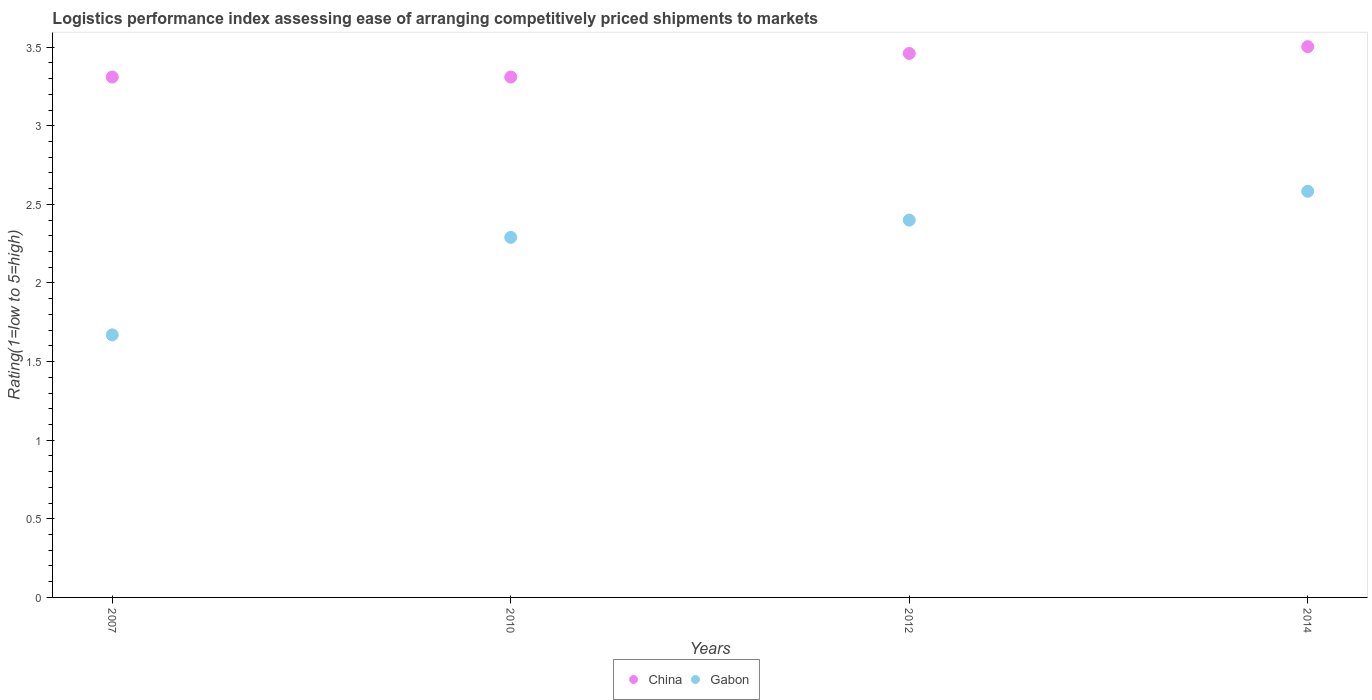Is the number of dotlines equal to the number of legend labels?
Give a very brief answer. Yes. What is the Logistic performance index in China in 2010?
Give a very brief answer. 3.31. Across all years, what is the maximum Logistic performance index in China?
Your answer should be compact. 3.5. Across all years, what is the minimum Logistic performance index in Gabon?
Your answer should be compact. 1.67. In which year was the Logistic performance index in China maximum?
Make the answer very short. 2014. What is the total Logistic performance index in China in the graph?
Keep it short and to the point. 13.58. What is the difference between the Logistic performance index in China in 2007 and that in 2014?
Offer a terse response. -0.19. What is the difference between the Logistic performance index in China in 2014 and the Logistic performance index in Gabon in 2007?
Your answer should be compact. 1.83. What is the average Logistic performance index in China per year?
Offer a very short reply. 3.4. In the year 2010, what is the difference between the Logistic performance index in Gabon and Logistic performance index in China?
Offer a very short reply. -1.02. In how many years, is the Logistic performance index in Gabon greater than 0.2?
Provide a succinct answer. 4. What is the ratio of the Logistic performance index in China in 2007 to that in 2010?
Keep it short and to the point. 1. Is the Logistic performance index in Gabon in 2007 less than that in 2014?
Your response must be concise. Yes. Is the difference between the Logistic performance index in Gabon in 2007 and 2014 greater than the difference between the Logistic performance index in China in 2007 and 2014?
Make the answer very short. No. What is the difference between the highest and the second highest Logistic performance index in Gabon?
Your response must be concise. 0.18. What is the difference between the highest and the lowest Logistic performance index in Gabon?
Ensure brevity in your answer.  0.91. Does the Logistic performance index in China monotonically increase over the years?
Your answer should be compact. No. Is the Logistic performance index in Gabon strictly greater than the Logistic performance index in China over the years?
Give a very brief answer. No. Is the Logistic performance index in Gabon strictly less than the Logistic performance index in China over the years?
Ensure brevity in your answer.  Yes. How many years are there in the graph?
Offer a terse response. 4. Are the values on the major ticks of Y-axis written in scientific E-notation?
Offer a terse response. No. How many legend labels are there?
Offer a terse response. 2. How are the legend labels stacked?
Give a very brief answer. Horizontal. What is the title of the graph?
Make the answer very short. Logistics performance index assessing ease of arranging competitively priced shipments to markets. What is the label or title of the X-axis?
Your response must be concise. Years. What is the label or title of the Y-axis?
Provide a short and direct response. Rating(1=low to 5=high). What is the Rating(1=low to 5=high) of China in 2007?
Give a very brief answer. 3.31. What is the Rating(1=low to 5=high) in Gabon in 2007?
Your answer should be compact. 1.67. What is the Rating(1=low to 5=high) in China in 2010?
Your answer should be very brief. 3.31. What is the Rating(1=low to 5=high) in Gabon in 2010?
Make the answer very short. 2.29. What is the Rating(1=low to 5=high) of China in 2012?
Keep it short and to the point. 3.46. What is the Rating(1=low to 5=high) of Gabon in 2012?
Keep it short and to the point. 2.4. What is the Rating(1=low to 5=high) of China in 2014?
Offer a terse response. 3.5. What is the Rating(1=low to 5=high) in Gabon in 2014?
Offer a terse response. 2.58. Across all years, what is the maximum Rating(1=low to 5=high) of China?
Your response must be concise. 3.5. Across all years, what is the maximum Rating(1=low to 5=high) in Gabon?
Make the answer very short. 2.58. Across all years, what is the minimum Rating(1=low to 5=high) of China?
Provide a succinct answer. 3.31. Across all years, what is the minimum Rating(1=low to 5=high) in Gabon?
Provide a short and direct response. 1.67. What is the total Rating(1=low to 5=high) in China in the graph?
Your answer should be very brief. 13.58. What is the total Rating(1=low to 5=high) of Gabon in the graph?
Make the answer very short. 8.94. What is the difference between the Rating(1=low to 5=high) of Gabon in 2007 and that in 2010?
Offer a very short reply. -0.62. What is the difference between the Rating(1=low to 5=high) in Gabon in 2007 and that in 2012?
Your answer should be compact. -0.73. What is the difference between the Rating(1=low to 5=high) of China in 2007 and that in 2014?
Provide a succinct answer. -0.19. What is the difference between the Rating(1=low to 5=high) of Gabon in 2007 and that in 2014?
Give a very brief answer. -0.91. What is the difference between the Rating(1=low to 5=high) in Gabon in 2010 and that in 2012?
Your response must be concise. -0.11. What is the difference between the Rating(1=low to 5=high) in China in 2010 and that in 2014?
Offer a terse response. -0.19. What is the difference between the Rating(1=low to 5=high) in Gabon in 2010 and that in 2014?
Provide a short and direct response. -0.29. What is the difference between the Rating(1=low to 5=high) in China in 2012 and that in 2014?
Your answer should be very brief. -0.04. What is the difference between the Rating(1=low to 5=high) in Gabon in 2012 and that in 2014?
Offer a very short reply. -0.18. What is the difference between the Rating(1=low to 5=high) of China in 2007 and the Rating(1=low to 5=high) of Gabon in 2010?
Ensure brevity in your answer.  1.02. What is the difference between the Rating(1=low to 5=high) of China in 2007 and the Rating(1=low to 5=high) of Gabon in 2012?
Ensure brevity in your answer.  0.91. What is the difference between the Rating(1=low to 5=high) in China in 2007 and the Rating(1=low to 5=high) in Gabon in 2014?
Provide a succinct answer. 0.73. What is the difference between the Rating(1=low to 5=high) in China in 2010 and the Rating(1=low to 5=high) in Gabon in 2012?
Offer a terse response. 0.91. What is the difference between the Rating(1=low to 5=high) in China in 2010 and the Rating(1=low to 5=high) in Gabon in 2014?
Keep it short and to the point. 0.73. What is the difference between the Rating(1=low to 5=high) in China in 2012 and the Rating(1=low to 5=high) in Gabon in 2014?
Give a very brief answer. 0.88. What is the average Rating(1=low to 5=high) in China per year?
Ensure brevity in your answer.  3.4. What is the average Rating(1=low to 5=high) in Gabon per year?
Offer a very short reply. 2.24. In the year 2007, what is the difference between the Rating(1=low to 5=high) of China and Rating(1=low to 5=high) of Gabon?
Provide a short and direct response. 1.64. In the year 2010, what is the difference between the Rating(1=low to 5=high) in China and Rating(1=low to 5=high) in Gabon?
Provide a short and direct response. 1.02. In the year 2012, what is the difference between the Rating(1=low to 5=high) in China and Rating(1=low to 5=high) in Gabon?
Provide a succinct answer. 1.06. In the year 2014, what is the difference between the Rating(1=low to 5=high) of China and Rating(1=low to 5=high) of Gabon?
Offer a very short reply. 0.92. What is the ratio of the Rating(1=low to 5=high) of China in 2007 to that in 2010?
Your answer should be very brief. 1. What is the ratio of the Rating(1=low to 5=high) in Gabon in 2007 to that in 2010?
Your answer should be compact. 0.73. What is the ratio of the Rating(1=low to 5=high) in China in 2007 to that in 2012?
Give a very brief answer. 0.96. What is the ratio of the Rating(1=low to 5=high) in Gabon in 2007 to that in 2012?
Offer a very short reply. 0.7. What is the ratio of the Rating(1=low to 5=high) of China in 2007 to that in 2014?
Provide a short and direct response. 0.94. What is the ratio of the Rating(1=low to 5=high) of Gabon in 2007 to that in 2014?
Make the answer very short. 0.65. What is the ratio of the Rating(1=low to 5=high) of China in 2010 to that in 2012?
Your response must be concise. 0.96. What is the ratio of the Rating(1=low to 5=high) of Gabon in 2010 to that in 2012?
Your answer should be very brief. 0.95. What is the ratio of the Rating(1=low to 5=high) in China in 2010 to that in 2014?
Keep it short and to the point. 0.94. What is the ratio of the Rating(1=low to 5=high) in Gabon in 2010 to that in 2014?
Offer a terse response. 0.89. What is the ratio of the Rating(1=low to 5=high) of China in 2012 to that in 2014?
Ensure brevity in your answer.  0.99. What is the ratio of the Rating(1=low to 5=high) in Gabon in 2012 to that in 2014?
Give a very brief answer. 0.93. What is the difference between the highest and the second highest Rating(1=low to 5=high) of China?
Your answer should be very brief. 0.04. What is the difference between the highest and the second highest Rating(1=low to 5=high) of Gabon?
Give a very brief answer. 0.18. What is the difference between the highest and the lowest Rating(1=low to 5=high) of China?
Offer a terse response. 0.19. What is the difference between the highest and the lowest Rating(1=low to 5=high) in Gabon?
Give a very brief answer. 0.91. 